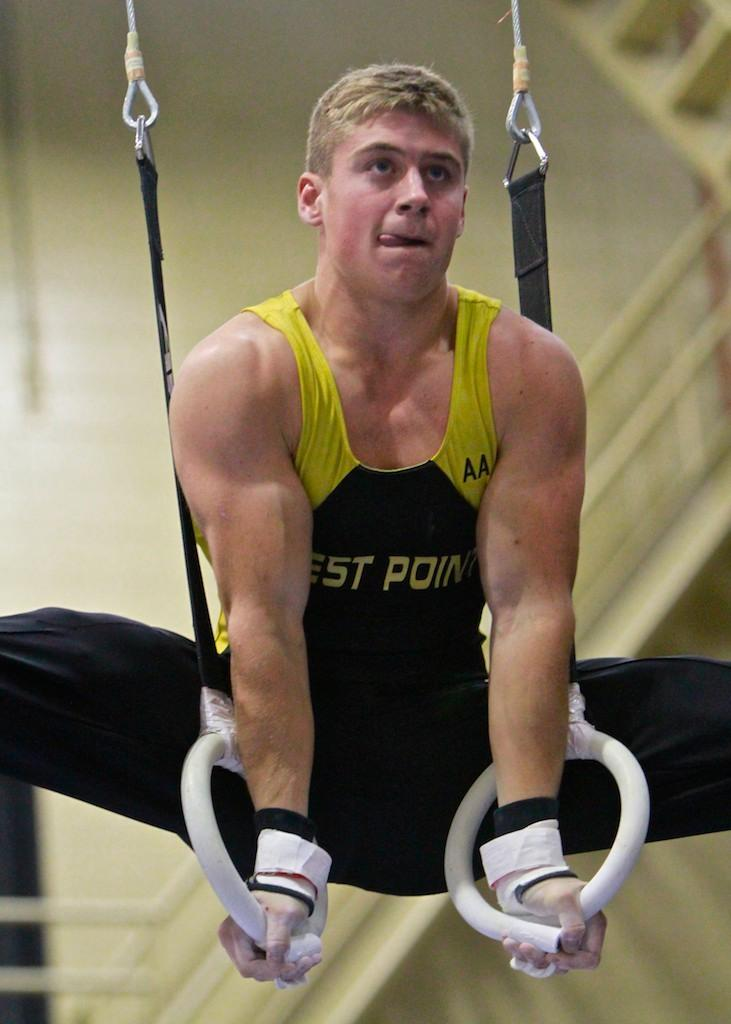What is the person in the image doing? The person is performing an exercise with rings. What can be seen in the background of the image? There is a wall in the background of the image. What type of wrist support is the person wearing while exercising with the rings? There is no wrist support visible in the image, and the person is not wearing any. 